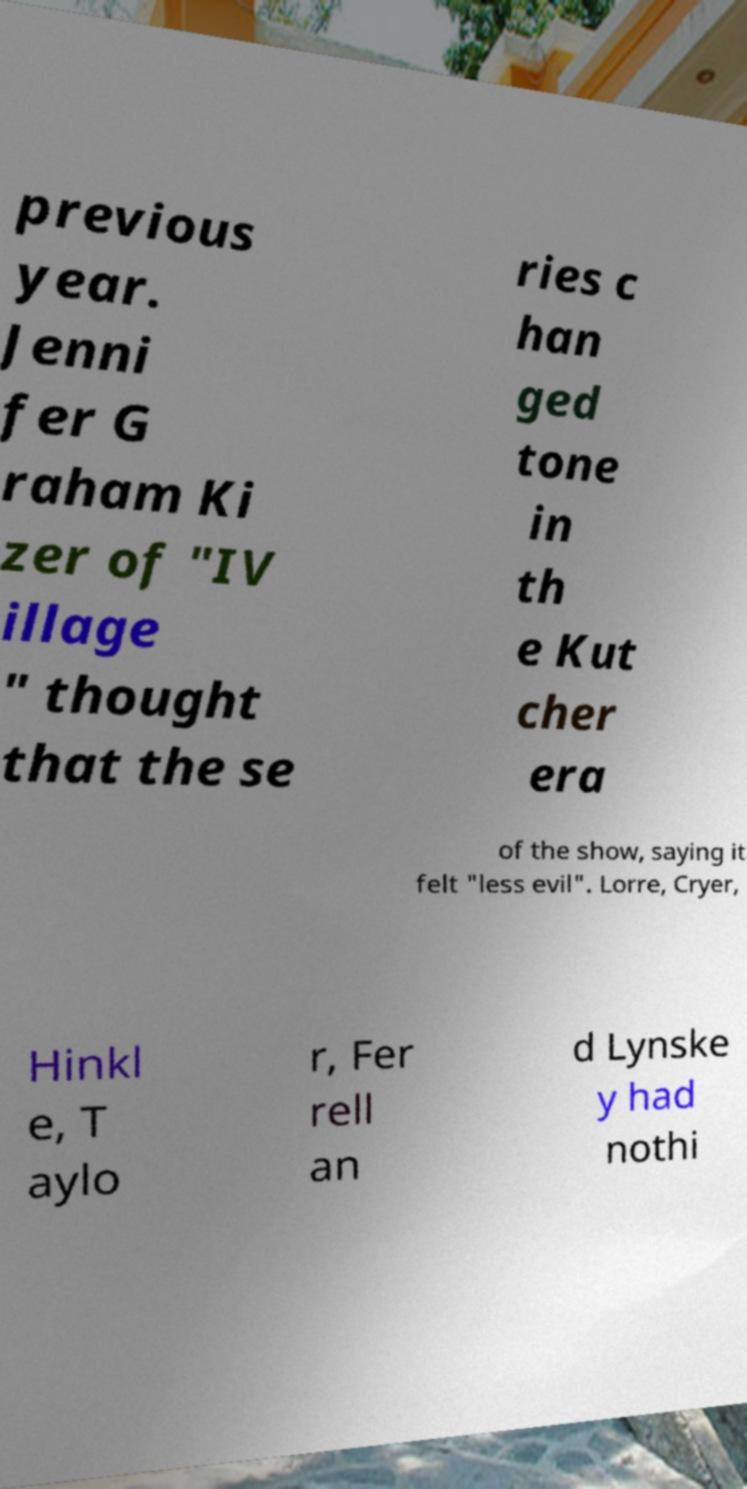For documentation purposes, I need the text within this image transcribed. Could you provide that? previous year. Jenni fer G raham Ki zer of "IV illage " thought that the se ries c han ged tone in th e Kut cher era of the show, saying it felt "less evil". Lorre, Cryer, Hinkl e, T aylo r, Fer rell an d Lynske y had nothi 